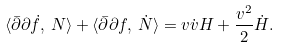<formula> <loc_0><loc_0><loc_500><loc_500>\langle \bar { \partial } \partial \dot { f } , \, N \rangle + \langle \bar { \partial } \partial f , \, \dot { N } \rangle = v \dot { v } H + \frac { v ^ { 2 } } { 2 } \dot { H } .</formula> 